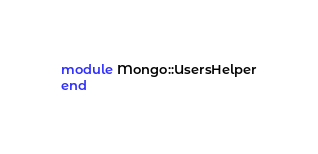Convert code to text. <code><loc_0><loc_0><loc_500><loc_500><_Ruby_>module Mongo::UsersHelper
end
</code> 